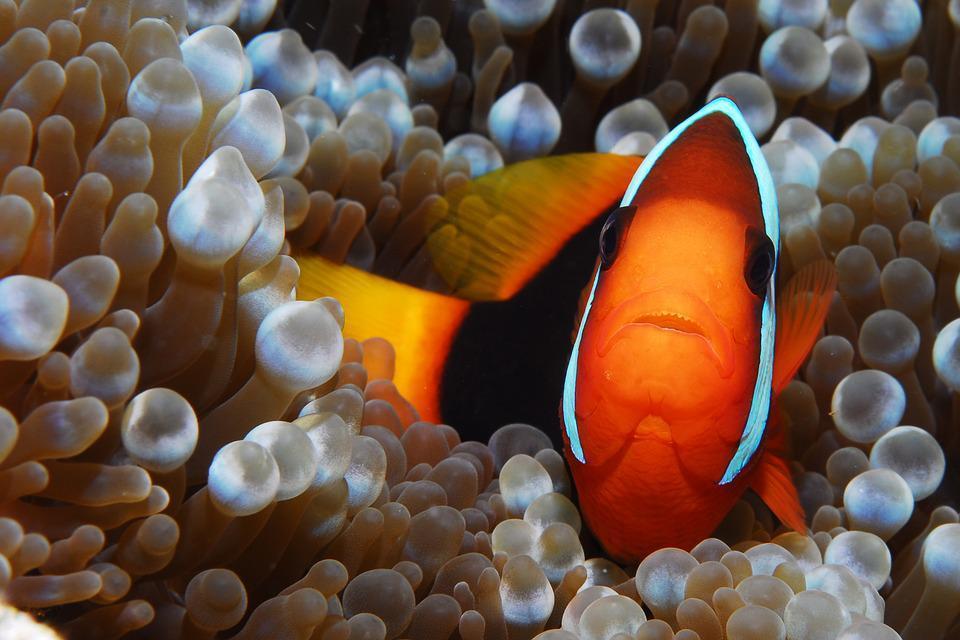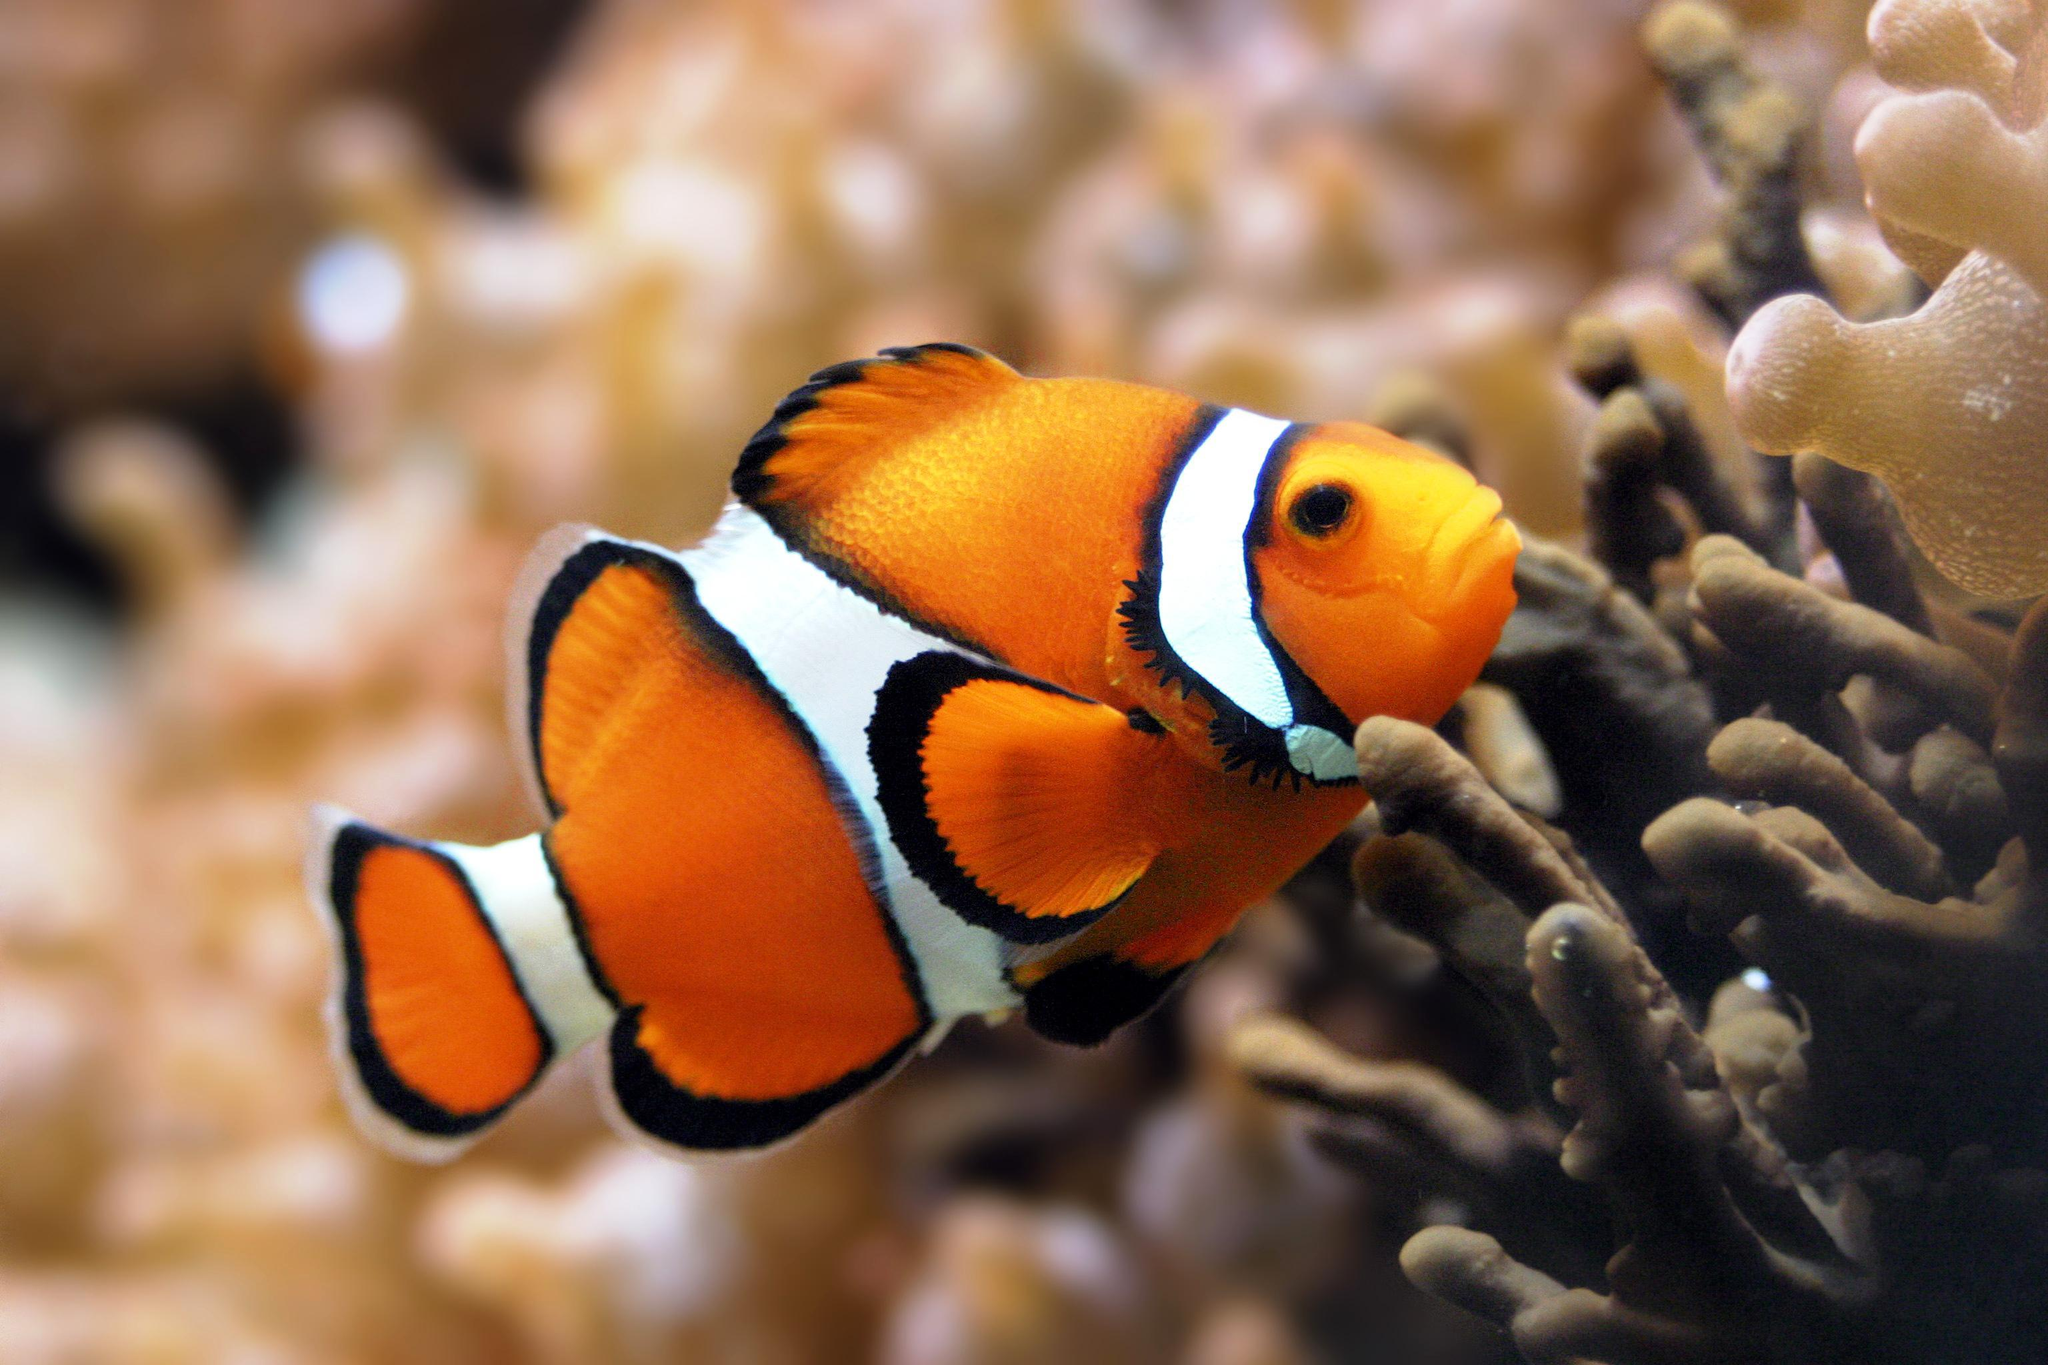The first image is the image on the left, the second image is the image on the right. For the images displayed, is the sentence "One single fish is swimming in the image on the right." factually correct? Answer yes or no. Yes. The first image is the image on the left, the second image is the image on the right. For the images displayed, is the sentence "Each image contains the same number of clown fish swimming among anemone tendrils." factually correct? Answer yes or no. Yes. 